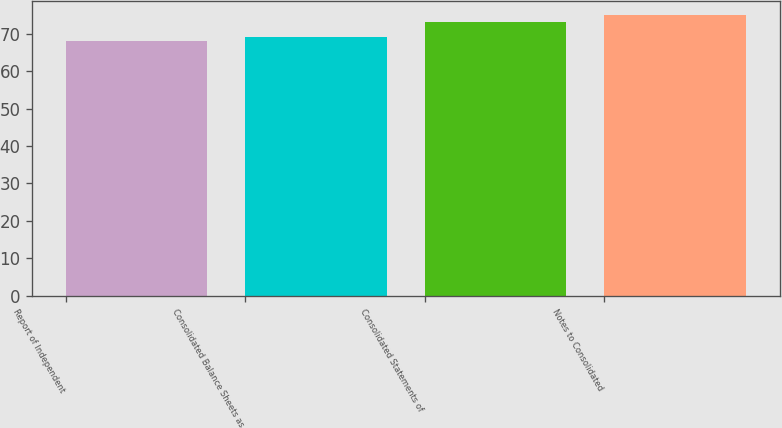Convert chart. <chart><loc_0><loc_0><loc_500><loc_500><bar_chart><fcel>Report of Independent<fcel>Consolidated Balance Sheets as<fcel>Consolidated Statements of<fcel>Notes to Consolidated<nl><fcel>68<fcel>69<fcel>73<fcel>75<nl></chart> 